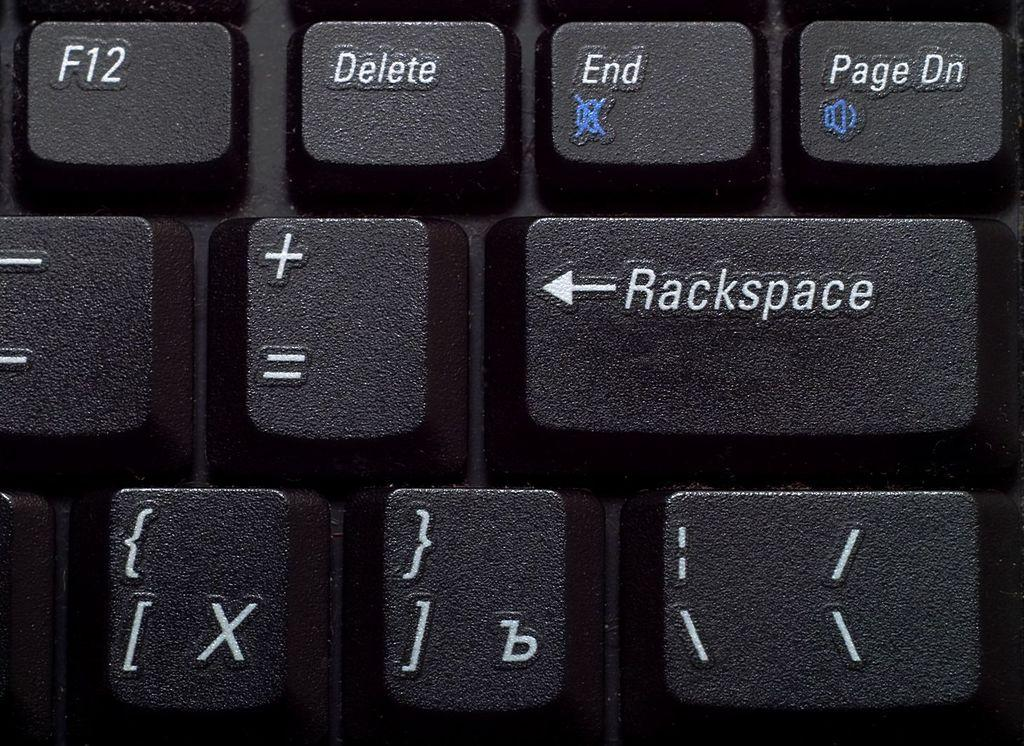<image>
Render a clear and concise summary of the photo. The "Rackspace" key is below the "End" key on the keyboard. 